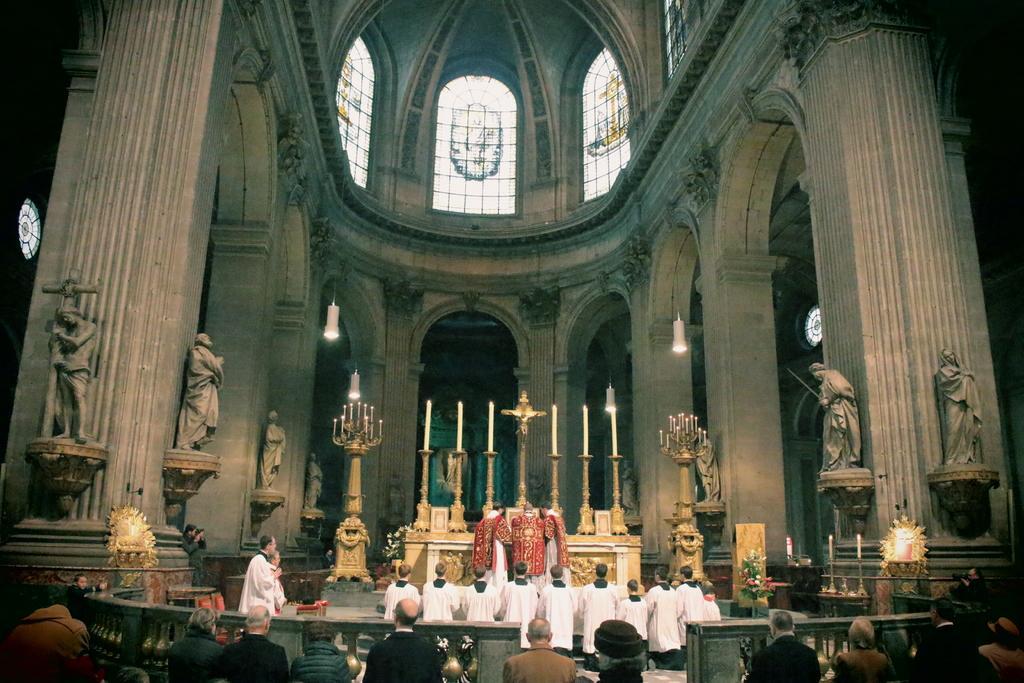How would you summarize this image in a sentence or two? To the bottom of the image there are few people standing and in front of them there is a railing. To the front of the railing there are few people with white dress is standing. And in front of them there are three men with white dress and red dress is standing in front of the table with a cross symbol on it. And also there are few poles with big candles on it. There are few poles with candles on the stage. And in the background there are few pillars with statues. And to the top of the image there are glass windows. 